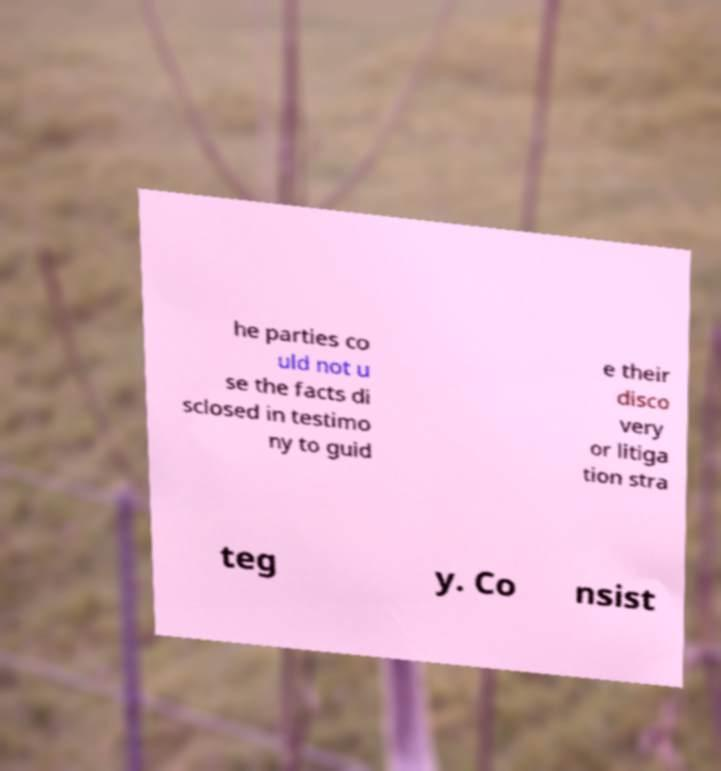What messages or text are displayed in this image? I need them in a readable, typed format. he parties co uld not u se the facts di sclosed in testimo ny to guid e their disco very or litiga tion stra teg y. Co nsist 